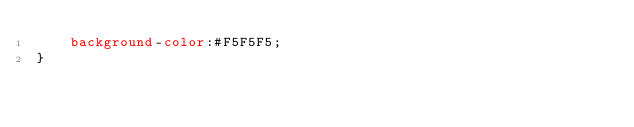Convert code to text. <code><loc_0><loc_0><loc_500><loc_500><_CSS_>    background-color:#F5F5F5;
}</code> 